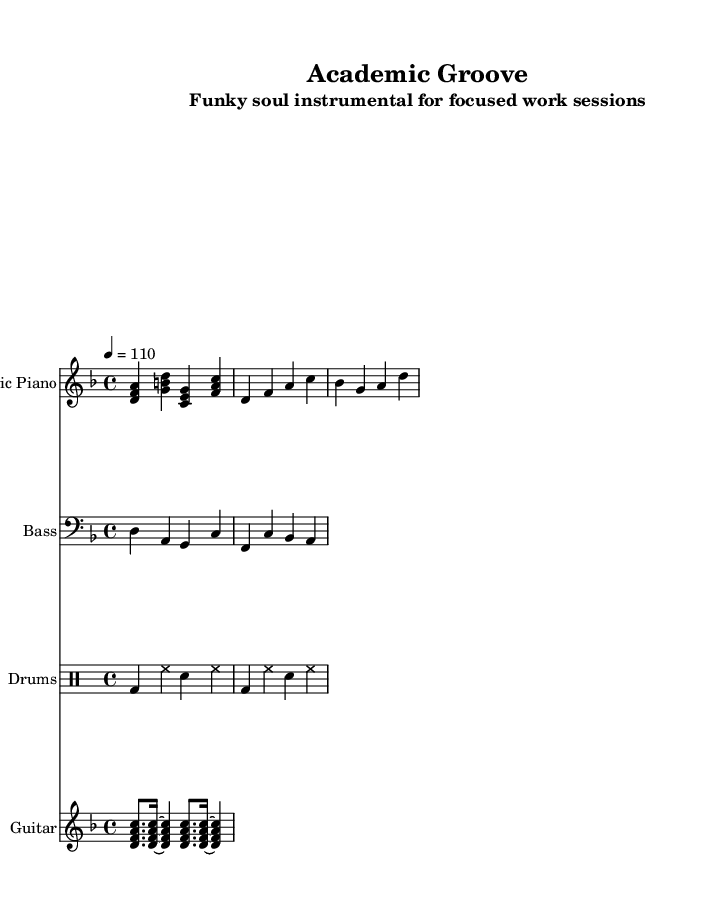What is the key signature of this music? The music is in the key of D minor, which has one flat (B flat). This is indicated by the presence of the B flat note shown in the bass guitar part and by the context of the key signature at the beginning of the sheet music.
Answer: D minor What is the time signature of this piece? The time signature is 4/4, which is indicated at the beginning of the score. This means there are four beats per measure, and the quarter note gets one beat.
Answer: 4/4 What is the tempo marking indicated in the sheet music? The tempo marking is 4 equals 110, which means that there are 110 beats per minute. This is specified next to the global settings at the beginning of the music.
Answer: 110 Which instrument plays the main chord progression? The electric piano plays the main chord progression, as shown in the first staff of the score where its notes are musically arranged in a manner characteristic of funk and soul themes.
Answer: Electric Piano How many measures are there in the electric piano part? The electric piano part consists of 4 measures, as indicated by the notation grouped into bars, each separated by a vertical line.
Answer: 4 Which section features drumming patterns that commonly support funk music? The drums part features a typical funk drumming pattern with a kick drum, snare, and hi-hat rhythm. This showcases syncopation and interlocking rhythms, both characteristic of funk.
Answer: Drums What is the primary function of the bass guitar in this piece? The primary function of the bass guitar is to provide the underlying groove and harmonic foundation for the piece, reinforcing rhythm and interaction with the electric piano.
Answer: Groove 